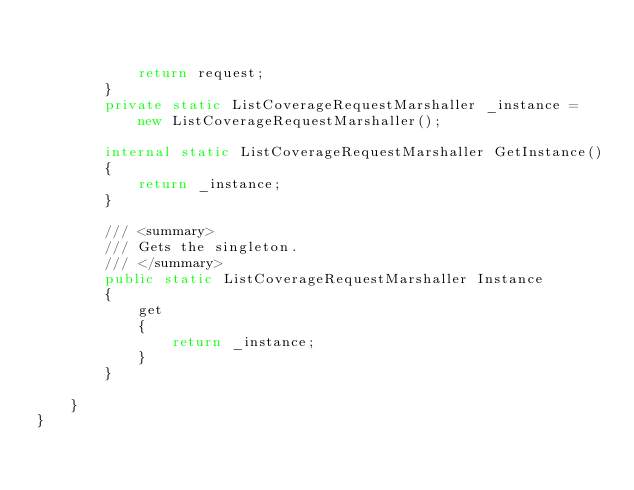Convert code to text. <code><loc_0><loc_0><loc_500><loc_500><_C#_>

            return request;
        }
        private static ListCoverageRequestMarshaller _instance = new ListCoverageRequestMarshaller();        

        internal static ListCoverageRequestMarshaller GetInstance()
        {
            return _instance;
        }

        /// <summary>
        /// Gets the singleton.
        /// </summary>  
        public static ListCoverageRequestMarshaller Instance
        {
            get
            {
                return _instance;
            }
        }

    }
}</code> 